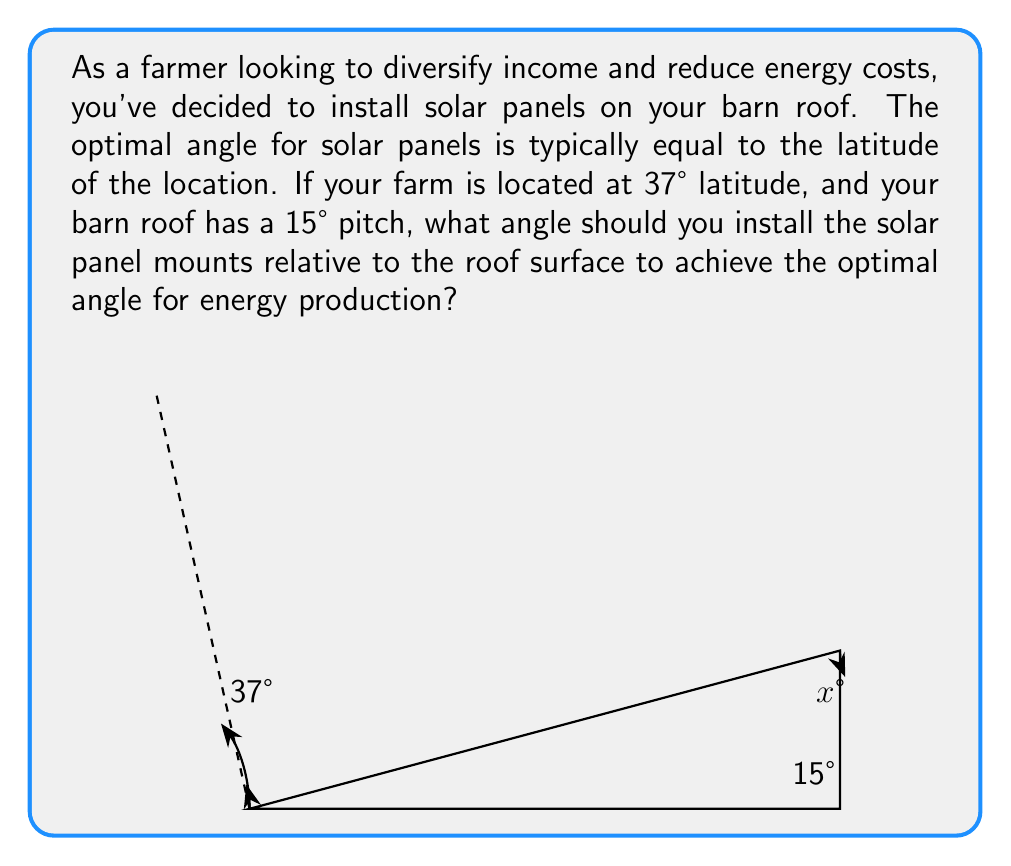Show me your answer to this math problem. Let's approach this step-by-step:

1) The optimal angle for the solar panels is equal to the latitude, which is 37°.

2) The roof already has a 15° pitch. This means we need to add an additional angle to reach 37°.

3) Let's call the additional angle we need to add $x°$.

4) We can set up an equation:
   
   $15° + x° = 37°$

5) Solving for $x$:
   
   $x° = 37° - 15°$
   $x° = 22°$

6) Therefore, the solar panel mounts should be installed at a 22° angle relative to the roof surface.

This can be verified geometrically:

$$\tan(37°) \approx 0.7536$$
$$\tan(15°) \approx 0.2679$$
$$\tan(22°) \approx 0.4040$$

And indeed:

$$\tan(15°) + \tan(22°) \approx 0.2679 + 0.4040 \approx 0.7719$$

Which is very close to $\tan(37°)$, with the small difference due to rounding and the fact that $\tan(A) + \tan(B) \neq \tan(A+B)$ exactly.
Answer: The solar panel mounts should be installed at a $22°$ angle relative to the roof surface. 